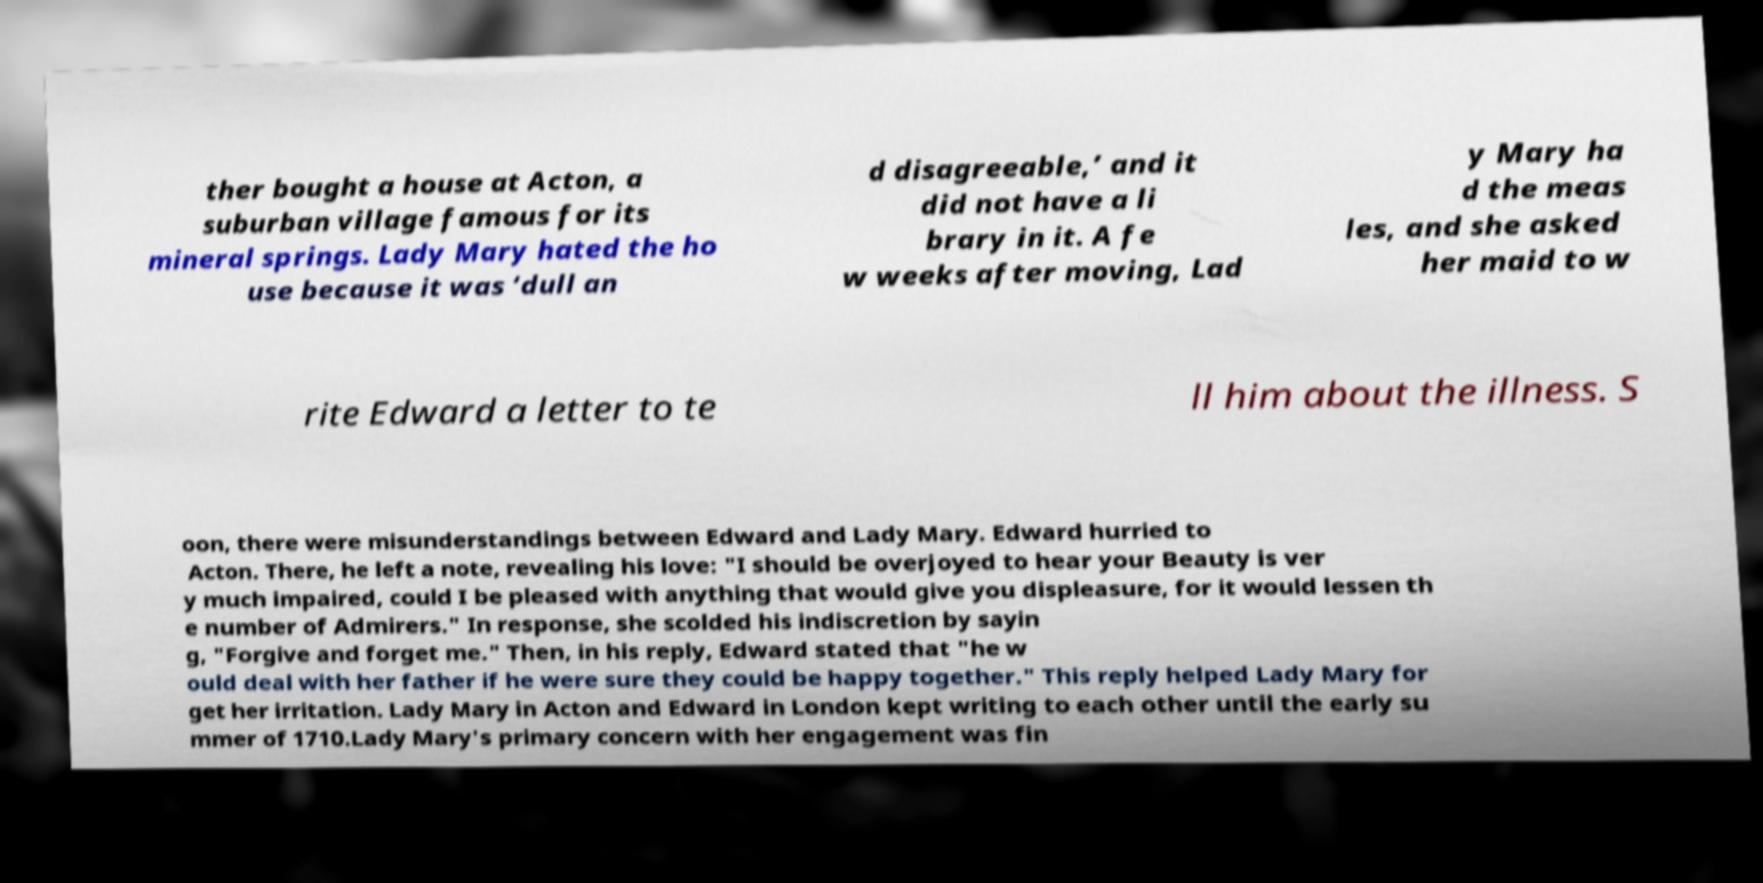There's text embedded in this image that I need extracted. Can you transcribe it verbatim? ther bought a house at Acton, a suburban village famous for its mineral springs. Lady Mary hated the ho use because it was ‘dull an d disagreeable,’ and it did not have a li brary in it. A fe w weeks after moving, Lad y Mary ha d the meas les, and she asked her maid to w rite Edward a letter to te ll him about the illness. S oon, there were misunderstandings between Edward and Lady Mary. Edward hurried to Acton. There, he left a note, revealing his love: "I should be overjoyed to hear your Beauty is ver y much impaired, could I be pleased with anything that would give you displeasure, for it would lessen th e number of Admirers." In response, she scolded his indiscretion by sayin g, "Forgive and forget me." Then, in his reply, Edward stated that "he w ould deal with her father if he were sure they could be happy together." This reply helped Lady Mary for get her irritation. Lady Mary in Acton and Edward in London kept writing to each other until the early su mmer of 1710.Lady Mary's primary concern with her engagement was fin 